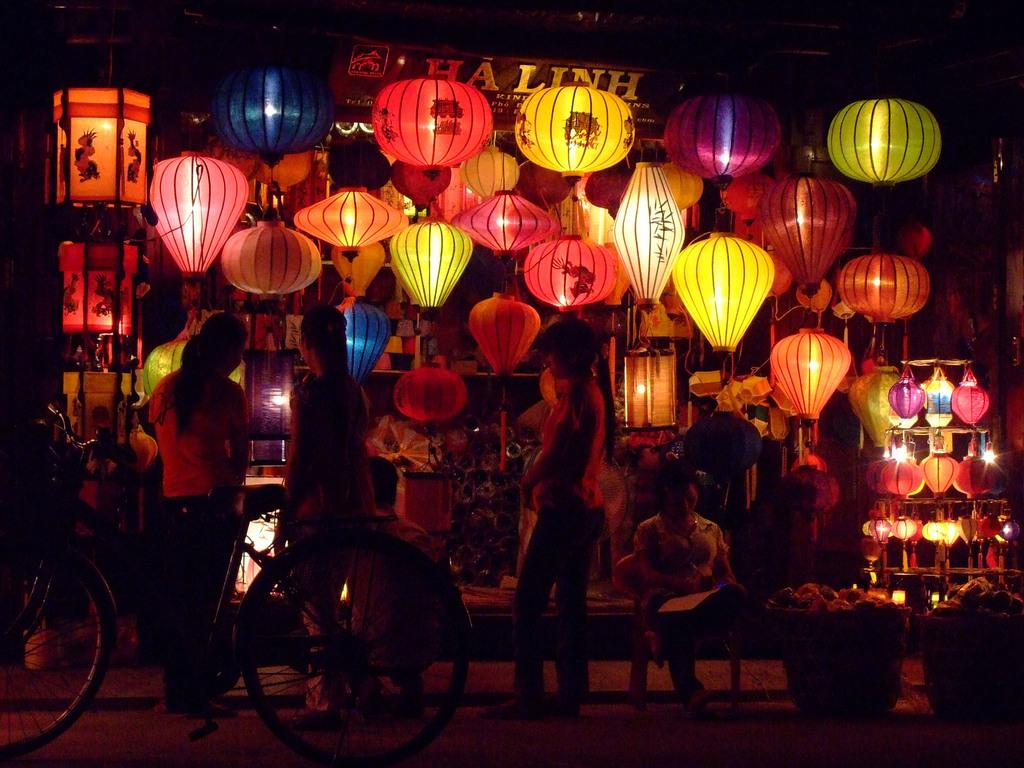What type of decorations are present in the image? There are Chinese lanterns in the image. Can you describe the people in the image? There are people in the image, but their specific actions or appearances are not mentioned in the facts. What mode of transportation can be seen in the image? There is a cycle in the image. What is the color of the background in the image? The background of the image is dark. What is written or displayed on the board in the image? There is a board with words written in the image, but the specific words or message are not mentioned in the facts. Are there any caves visible in the image? There is no mention of a cave in the image, so it cannot be confirmed or denied. What type of stone is used to create the feather in the image? There is no feather present in the image, so it is not possible to determine the type of stone used to create it. 